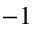<formula> <loc_0><loc_0><loc_500><loc_500>^ { - 1 }</formula> 